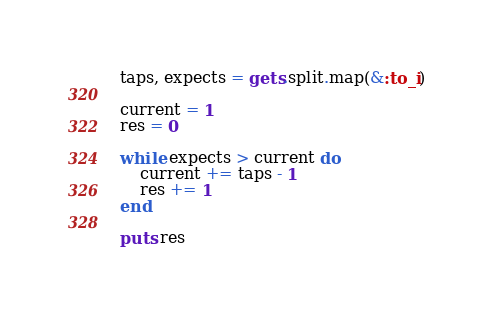<code> <loc_0><loc_0><loc_500><loc_500><_Ruby_>taps, expects = gets.split.map(&:to_i)

current = 1
res = 0

while expects > current do
    current += taps - 1
    res += 1
end

puts res</code> 